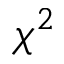Convert formula to latex. <formula><loc_0><loc_0><loc_500><loc_500>\chi ^ { 2 }</formula> 